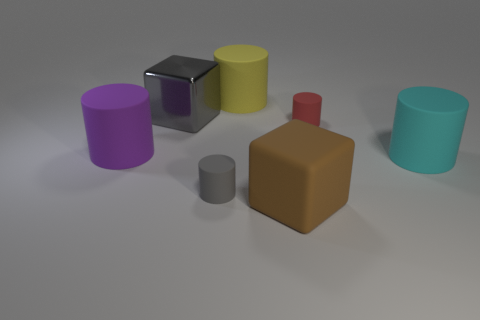Subtract all brown cylinders. Subtract all brown cubes. How many cylinders are left? 5 Add 2 gray matte objects. How many objects exist? 9 Subtract all cylinders. How many objects are left? 2 Subtract 0 green cubes. How many objects are left? 7 Subtract all red rubber cylinders. Subtract all big green rubber cubes. How many objects are left? 6 Add 1 red matte things. How many red matte things are left? 2 Add 5 small objects. How many small objects exist? 7 